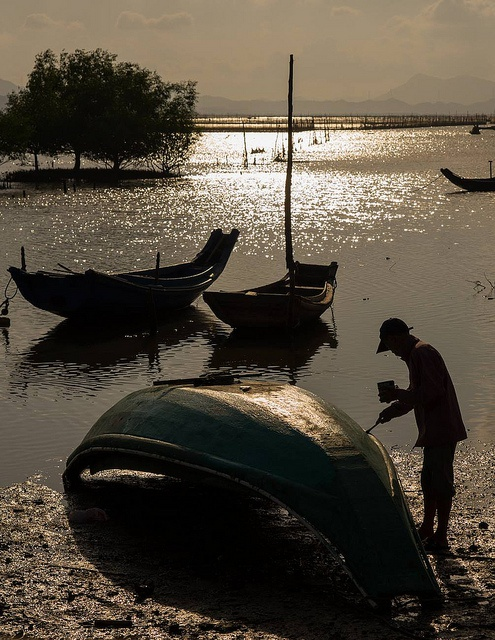Describe the objects in this image and their specific colors. I can see boat in gray, black, and tan tones, boat in gray and black tones, people in gray and black tones, boat in gray and black tones, and boat in gray and black tones in this image. 